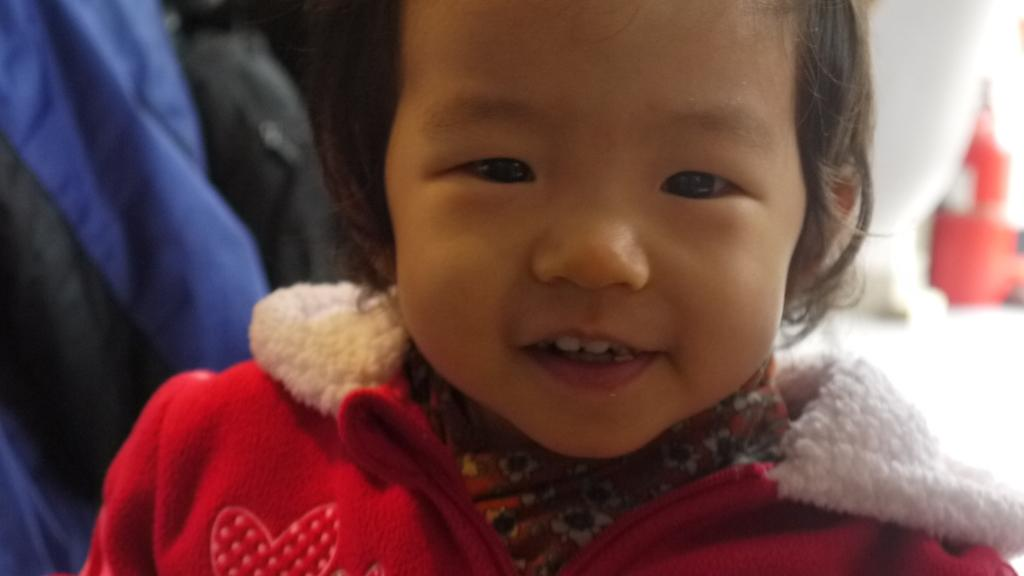What is the main subject in the foreground of the image? There is a baby in the foreground of the image. What is the baby doing in the image? The baby is smiling. Can you describe the background of the image? There are objects in the background of the image. How many gold geese are sitting on the baby's head in the image? There are no gold geese present in the image, and therefore none are sitting on the baby's head. 